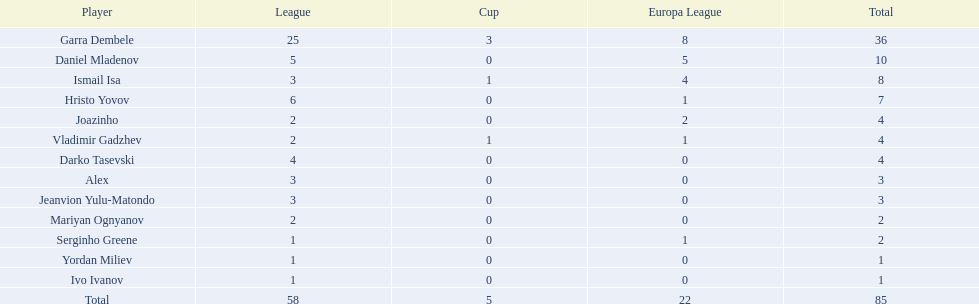Who are all of the players? Garra Dembele, Daniel Mladenov, Ismail Isa, Hristo Yovov, Joazinho, Vladimir Gadzhev, Darko Tasevski, Alex, Jeanvion Yulu-Matondo, Mariyan Ognyanov, Serginho Greene, Yordan Miliev, Ivo Ivanov. And which league is each player in? 25, 5, 3, 6, 2, 2, 4, 3, 3, 2, 1, 1, 1. Along with vladimir gadzhev and joazinho, which other player is in league 2? Mariyan Ognyanov. Parse the table in full. {'header': ['Player', 'League', 'Cup', 'Europa League', 'Total'], 'rows': [['Garra Dembele', '25', '3', '8', '36'], ['Daniel Mladenov', '5', '0', '5', '10'], ['Ismail Isa', '3', '1', '4', '8'], ['Hristo Yovov', '6', '0', '1', '7'], ['Joazinho', '2', '0', '2', '4'], ['Vladimir Gadzhev', '2', '1', '1', '4'], ['Darko Tasevski', '4', '0', '0', '4'], ['Alex', '3', '0', '0', '3'], ['Jeanvion Yulu-Matondo', '3', '0', '0', '3'], ['Mariyan Ognyanov', '2', '0', '0', '2'], ['Serginho Greene', '1', '0', '1', '2'], ['Yordan Miliev', '1', '0', '0', '1'], ['Ivo Ivanov', '1', '0', '0', '1'], ['Total', '58', '5', '22', '85']]} 